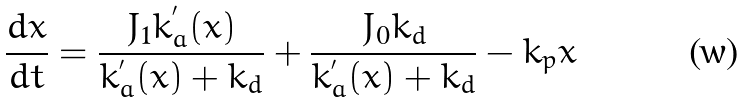<formula> <loc_0><loc_0><loc_500><loc_500>\frac { d x } { d t } = \frac { J _ { 1 } k _ { a } ^ { ^ { \prime } } ( x ) } { k _ { a } ^ { ^ { \prime } } ( x ) + k _ { d } } + \frac { J _ { 0 } k _ { d } } { k _ { a } ^ { ^ { \prime } } ( x ) + k _ { d } } - k _ { p } x</formula> 